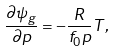Convert formula to latex. <formula><loc_0><loc_0><loc_500><loc_500>\frac { \partial \psi _ { g } } { \partial p } = - \frac { R } { f _ { 0 } p } T ,</formula> 